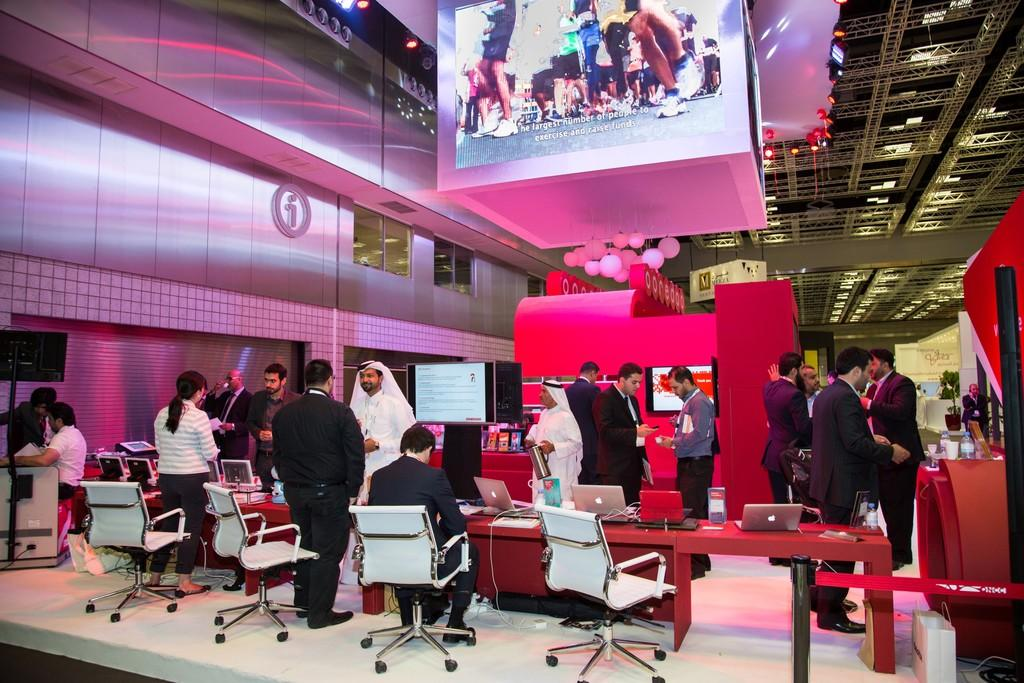What is the primary activity of the people in the image? There are many people standing on the floor, but the specific activity is not mentioned in the facts. What type of furniture is present in the image? There are chairs in the image. What electronic devices can be seen on the table? There are laptops on the table. What type of display devices are present in the image? There are many monitors in the image. What decorative items are present in the image? There are balloons in the image. What type of thread is being used to sew the skate in the image? There is no skate or thread present in the image. How many bits are visible on the monitors in the image? The provided facts do not mention any specific details about the content displayed on the monitors, so we cannot determine the number of bits visible. 